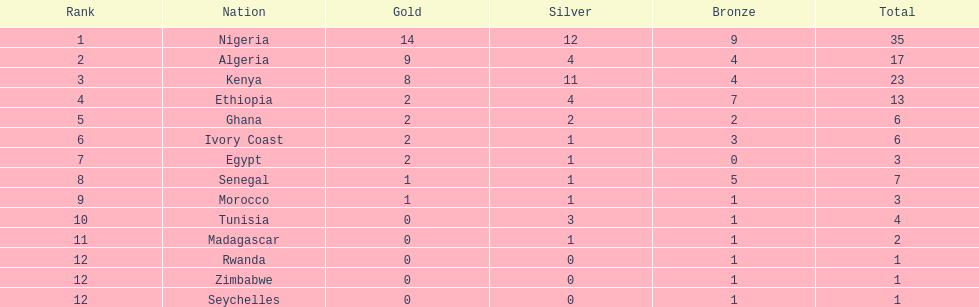How many medals has the ivory coast secured in total? 6. 